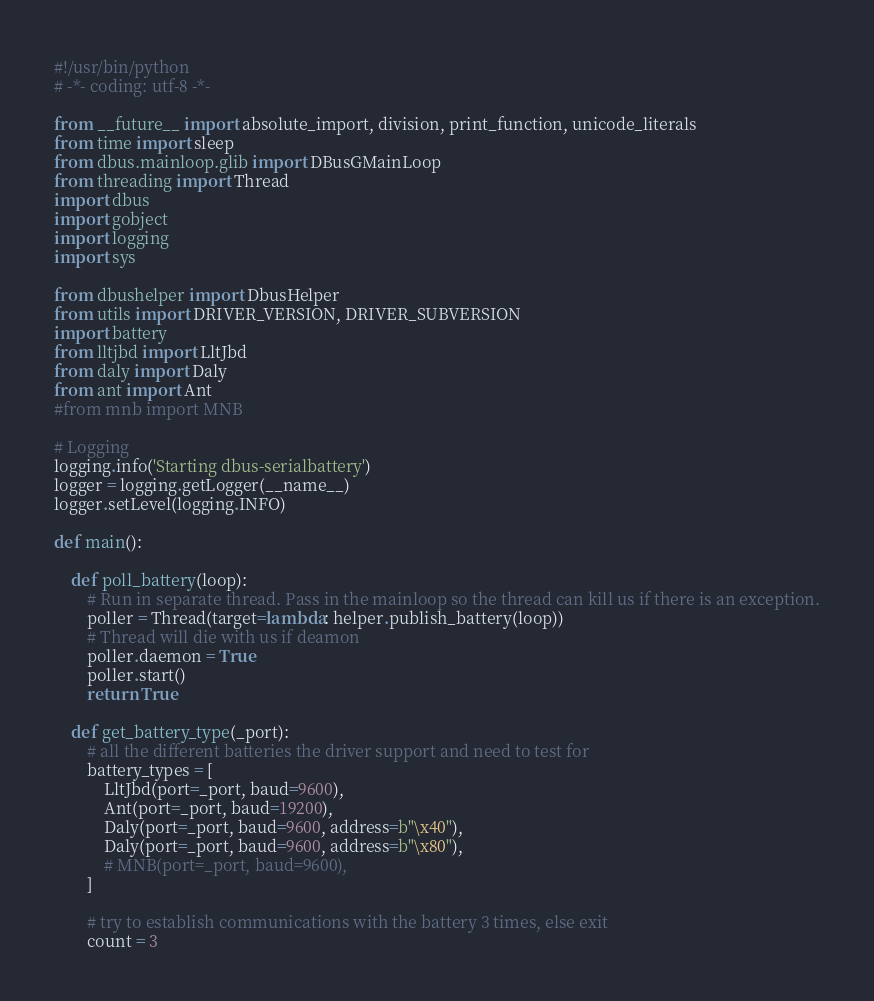Convert code to text. <code><loc_0><loc_0><loc_500><loc_500><_Python_>#!/usr/bin/python
# -*- coding: utf-8 -*-

from __future__ import absolute_import, division, print_function, unicode_literals
from time import sleep
from dbus.mainloop.glib import DBusGMainLoop
from threading import Thread
import dbus
import gobject
import logging
import sys

from dbushelper import DbusHelper
from utils import DRIVER_VERSION, DRIVER_SUBVERSION
import battery
from lltjbd import LltJbd
from daly import Daly
from ant import Ant
#from mnb import MNB

# Logging
logging.info('Starting dbus-serialbattery')
logger = logging.getLogger(__name__)
logger.setLevel(logging.INFO)

def main():

    def poll_battery(loop):
        # Run in separate thread. Pass in the mainloop so the thread can kill us if there is an exception.
        poller = Thread(target=lambda: helper.publish_battery(loop))
        # Thread will die with us if deamon
        poller.daemon = True
        poller.start()
        return True

    def get_battery_type(_port):
        # all the different batteries the driver support and need to test for
        battery_types = [
            LltJbd(port=_port, baud=9600),
            Ant(port=_port, baud=19200),
            Daly(port=_port, baud=9600, address=b"\x40"),
            Daly(port=_port, baud=9600, address=b"\x80"),
            # MNB(port=_port, baud=9600),
        ]

        # try to establish communications with the battery 3 times, else exit
        count = 3</code> 